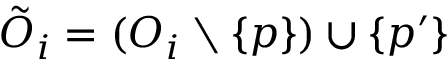<formula> <loc_0><loc_0><loc_500><loc_500>\tilde { O } _ { i } = ( O _ { i } \ \{ p \} ) \cup \{ p ^ { \prime } \}</formula> 